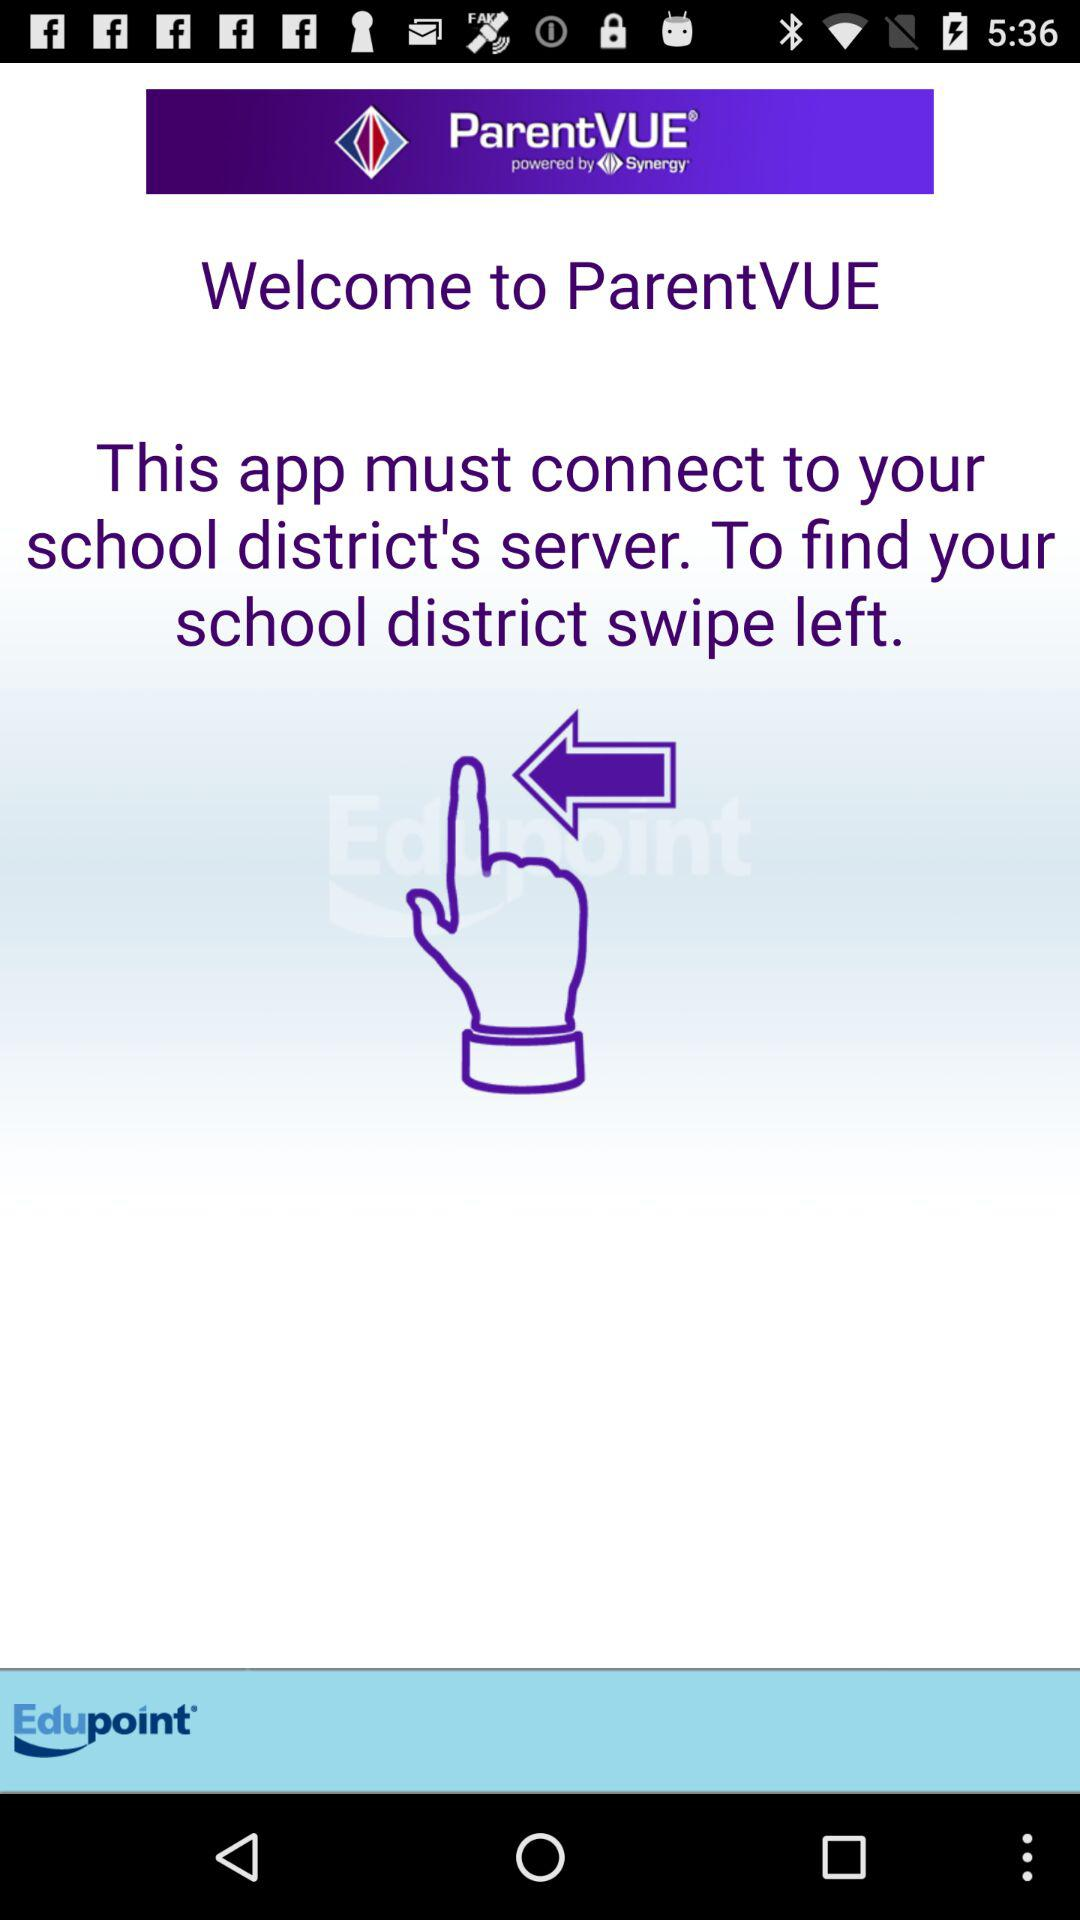What is the app name? The app name is "ParentVUE". 